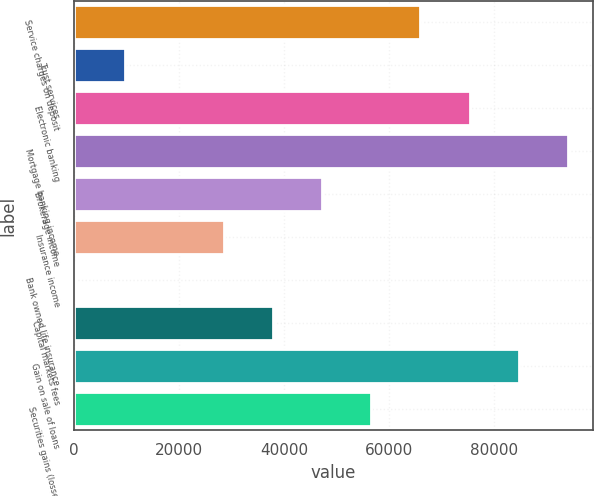Convert chart to OTSL. <chart><loc_0><loc_0><loc_500><loc_500><bar_chart><fcel>Service charges on deposit<fcel>Trust services<fcel>Electronic banking<fcel>Mortgage banking income<fcel>Brokerage income<fcel>Insurance income<fcel>Bank owned life insurance<fcel>Capital markets fees<fcel>Gain on sale of loans<fcel>Securities gains (losses)<nl><fcel>66000.6<fcel>9751.8<fcel>75375.4<fcel>94125<fcel>47251<fcel>28501.4<fcel>377<fcel>37876.2<fcel>84750.2<fcel>56625.8<nl></chart> 